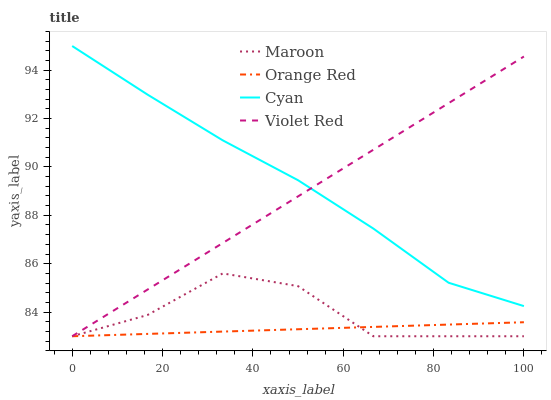Does Violet Red have the minimum area under the curve?
Answer yes or no. No. Does Violet Red have the maximum area under the curve?
Answer yes or no. No. Is Orange Red the smoothest?
Answer yes or no. No. Is Orange Red the roughest?
Answer yes or no. No. Does Violet Red have the highest value?
Answer yes or no. No. Is Orange Red less than Cyan?
Answer yes or no. Yes. Is Cyan greater than Orange Red?
Answer yes or no. Yes. Does Orange Red intersect Cyan?
Answer yes or no. No. 